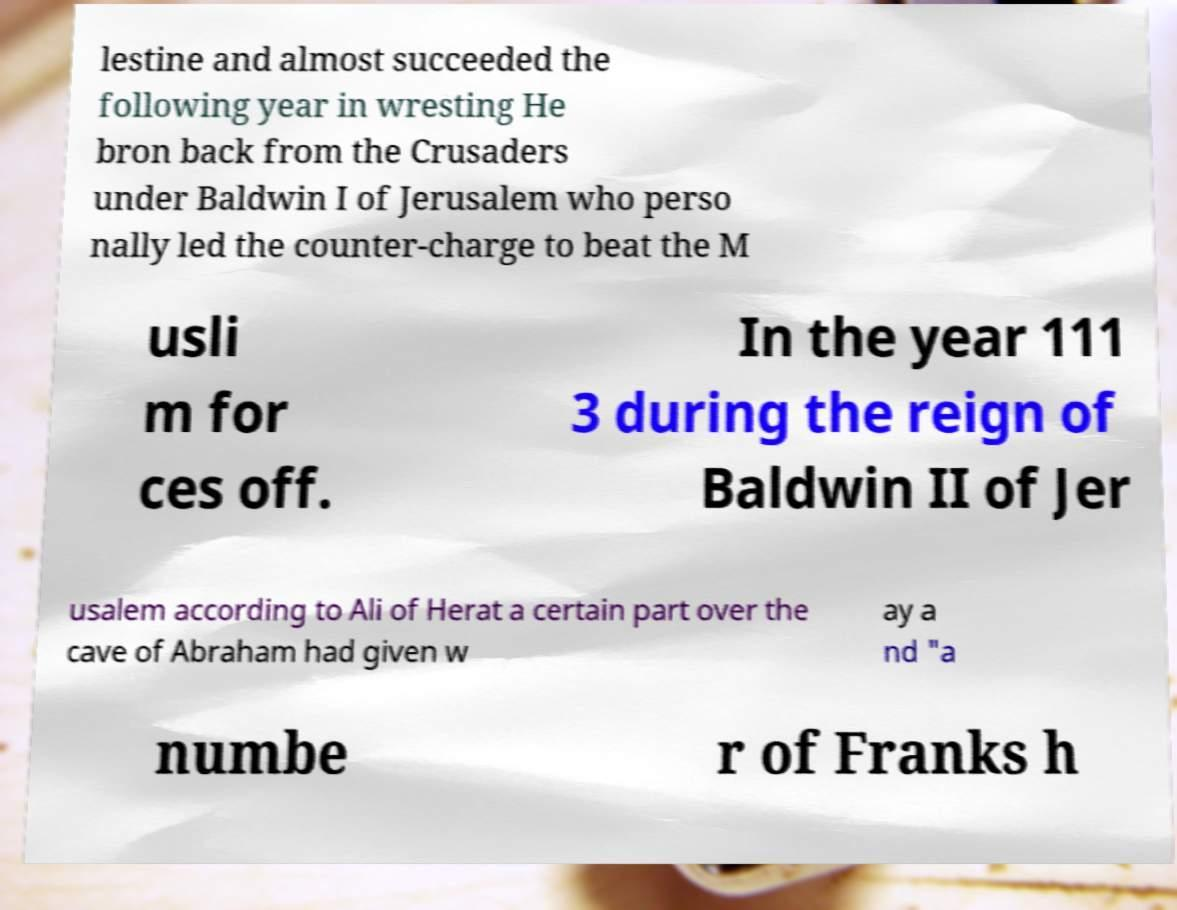There's text embedded in this image that I need extracted. Can you transcribe it verbatim? lestine and almost succeeded the following year in wresting He bron back from the Crusaders under Baldwin I of Jerusalem who perso nally led the counter-charge to beat the M usli m for ces off. In the year 111 3 during the reign of Baldwin II of Jer usalem according to Ali of Herat a certain part over the cave of Abraham had given w ay a nd "a numbe r of Franks h 